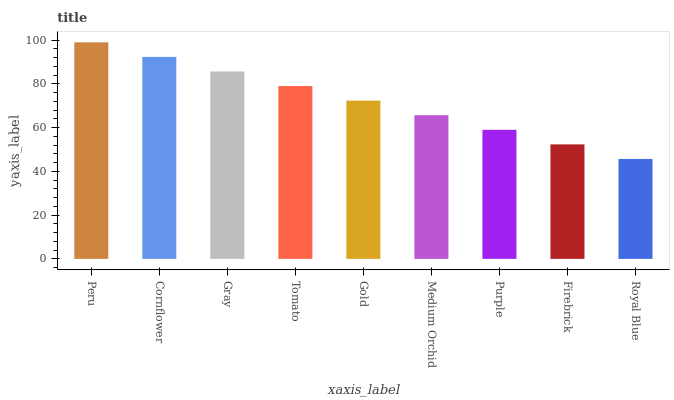Is Royal Blue the minimum?
Answer yes or no. Yes. Is Peru the maximum?
Answer yes or no. Yes. Is Cornflower the minimum?
Answer yes or no. No. Is Cornflower the maximum?
Answer yes or no. No. Is Peru greater than Cornflower?
Answer yes or no. Yes. Is Cornflower less than Peru?
Answer yes or no. Yes. Is Cornflower greater than Peru?
Answer yes or no. No. Is Peru less than Cornflower?
Answer yes or no. No. Is Gold the high median?
Answer yes or no. Yes. Is Gold the low median?
Answer yes or no. Yes. Is Firebrick the high median?
Answer yes or no. No. Is Cornflower the low median?
Answer yes or no. No. 